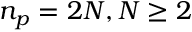<formula> <loc_0><loc_0><loc_500><loc_500>n _ { p } = 2 N , N \geq 2</formula> 